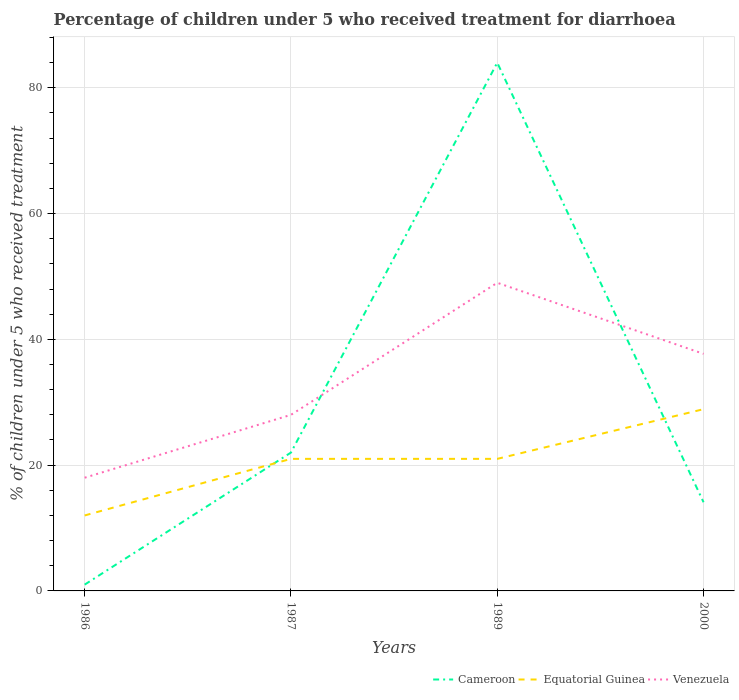How many different coloured lines are there?
Keep it short and to the point. 3. Does the line corresponding to Venezuela intersect with the line corresponding to Cameroon?
Offer a terse response. Yes. What is the total percentage of children who received treatment for diarrhoea  in Venezuela in the graph?
Provide a succinct answer. 11.3. Is the percentage of children who received treatment for diarrhoea  in Equatorial Guinea strictly greater than the percentage of children who received treatment for diarrhoea  in Cameroon over the years?
Offer a very short reply. No. How many years are there in the graph?
Your response must be concise. 4. What is the difference between two consecutive major ticks on the Y-axis?
Your response must be concise. 20. Are the values on the major ticks of Y-axis written in scientific E-notation?
Give a very brief answer. No. Does the graph contain grids?
Give a very brief answer. Yes. Where does the legend appear in the graph?
Keep it short and to the point. Bottom right. What is the title of the graph?
Your answer should be very brief. Percentage of children under 5 who received treatment for diarrhoea. Does "High income: OECD" appear as one of the legend labels in the graph?
Your answer should be compact. No. What is the label or title of the X-axis?
Your answer should be compact. Years. What is the label or title of the Y-axis?
Your answer should be very brief. % of children under 5 who received treatment. What is the % of children under 5 who received treatment of Cameroon in 1987?
Keep it short and to the point. 22. What is the % of children under 5 who received treatment in Equatorial Guinea in 1987?
Offer a very short reply. 21. What is the % of children under 5 who received treatment in Venezuela in 1987?
Give a very brief answer. 28. What is the % of children under 5 who received treatment of Equatorial Guinea in 1989?
Offer a terse response. 21. What is the % of children under 5 who received treatment of Venezuela in 1989?
Keep it short and to the point. 49. What is the % of children under 5 who received treatment in Equatorial Guinea in 2000?
Provide a succinct answer. 28.9. What is the % of children under 5 who received treatment in Venezuela in 2000?
Ensure brevity in your answer.  37.7. Across all years, what is the maximum % of children under 5 who received treatment in Cameroon?
Make the answer very short. 84. Across all years, what is the maximum % of children under 5 who received treatment of Equatorial Guinea?
Make the answer very short. 28.9. Across all years, what is the maximum % of children under 5 who received treatment in Venezuela?
Your answer should be compact. 49. Across all years, what is the minimum % of children under 5 who received treatment in Cameroon?
Give a very brief answer. 1. What is the total % of children under 5 who received treatment of Cameroon in the graph?
Your response must be concise. 121.1. What is the total % of children under 5 who received treatment in Equatorial Guinea in the graph?
Your answer should be compact. 82.9. What is the total % of children under 5 who received treatment in Venezuela in the graph?
Ensure brevity in your answer.  132.7. What is the difference between the % of children under 5 who received treatment in Cameroon in 1986 and that in 1989?
Your answer should be very brief. -83. What is the difference between the % of children under 5 who received treatment in Venezuela in 1986 and that in 1989?
Your response must be concise. -31. What is the difference between the % of children under 5 who received treatment in Cameroon in 1986 and that in 2000?
Your answer should be compact. -13.1. What is the difference between the % of children under 5 who received treatment of Equatorial Guinea in 1986 and that in 2000?
Offer a terse response. -16.9. What is the difference between the % of children under 5 who received treatment in Venezuela in 1986 and that in 2000?
Your answer should be compact. -19.7. What is the difference between the % of children under 5 who received treatment in Cameroon in 1987 and that in 1989?
Provide a short and direct response. -62. What is the difference between the % of children under 5 who received treatment of Equatorial Guinea in 1987 and that in 1989?
Make the answer very short. 0. What is the difference between the % of children under 5 who received treatment of Equatorial Guinea in 1987 and that in 2000?
Provide a short and direct response. -7.9. What is the difference between the % of children under 5 who received treatment in Cameroon in 1989 and that in 2000?
Ensure brevity in your answer.  69.9. What is the difference between the % of children under 5 who received treatment in Cameroon in 1986 and the % of children under 5 who received treatment in Equatorial Guinea in 1987?
Provide a short and direct response. -20. What is the difference between the % of children under 5 who received treatment of Cameroon in 1986 and the % of children under 5 who received treatment of Venezuela in 1987?
Make the answer very short. -27. What is the difference between the % of children under 5 who received treatment of Equatorial Guinea in 1986 and the % of children under 5 who received treatment of Venezuela in 1987?
Provide a short and direct response. -16. What is the difference between the % of children under 5 who received treatment in Cameroon in 1986 and the % of children under 5 who received treatment in Venezuela in 1989?
Provide a succinct answer. -48. What is the difference between the % of children under 5 who received treatment in Equatorial Guinea in 1986 and the % of children under 5 who received treatment in Venezuela in 1989?
Your response must be concise. -37. What is the difference between the % of children under 5 who received treatment in Cameroon in 1986 and the % of children under 5 who received treatment in Equatorial Guinea in 2000?
Your answer should be very brief. -27.9. What is the difference between the % of children under 5 who received treatment in Cameroon in 1986 and the % of children under 5 who received treatment in Venezuela in 2000?
Your answer should be compact. -36.7. What is the difference between the % of children under 5 who received treatment of Equatorial Guinea in 1986 and the % of children under 5 who received treatment of Venezuela in 2000?
Make the answer very short. -25.7. What is the difference between the % of children under 5 who received treatment of Cameroon in 1987 and the % of children under 5 who received treatment of Venezuela in 1989?
Ensure brevity in your answer.  -27. What is the difference between the % of children under 5 who received treatment in Equatorial Guinea in 1987 and the % of children under 5 who received treatment in Venezuela in 1989?
Give a very brief answer. -28. What is the difference between the % of children under 5 who received treatment in Cameroon in 1987 and the % of children under 5 who received treatment in Equatorial Guinea in 2000?
Give a very brief answer. -6.9. What is the difference between the % of children under 5 who received treatment of Cameroon in 1987 and the % of children under 5 who received treatment of Venezuela in 2000?
Offer a very short reply. -15.7. What is the difference between the % of children under 5 who received treatment of Equatorial Guinea in 1987 and the % of children under 5 who received treatment of Venezuela in 2000?
Your answer should be very brief. -16.7. What is the difference between the % of children under 5 who received treatment in Cameroon in 1989 and the % of children under 5 who received treatment in Equatorial Guinea in 2000?
Your answer should be compact. 55.1. What is the difference between the % of children under 5 who received treatment in Cameroon in 1989 and the % of children under 5 who received treatment in Venezuela in 2000?
Your response must be concise. 46.3. What is the difference between the % of children under 5 who received treatment of Equatorial Guinea in 1989 and the % of children under 5 who received treatment of Venezuela in 2000?
Make the answer very short. -16.7. What is the average % of children under 5 who received treatment in Cameroon per year?
Ensure brevity in your answer.  30.27. What is the average % of children under 5 who received treatment in Equatorial Guinea per year?
Provide a succinct answer. 20.73. What is the average % of children under 5 who received treatment of Venezuela per year?
Keep it short and to the point. 33.17. In the year 1986, what is the difference between the % of children under 5 who received treatment of Cameroon and % of children under 5 who received treatment of Equatorial Guinea?
Ensure brevity in your answer.  -11. In the year 1986, what is the difference between the % of children under 5 who received treatment of Equatorial Guinea and % of children under 5 who received treatment of Venezuela?
Make the answer very short. -6. In the year 1987, what is the difference between the % of children under 5 who received treatment in Cameroon and % of children under 5 who received treatment in Equatorial Guinea?
Your answer should be very brief. 1. In the year 1987, what is the difference between the % of children under 5 who received treatment in Cameroon and % of children under 5 who received treatment in Venezuela?
Provide a short and direct response. -6. In the year 1989, what is the difference between the % of children under 5 who received treatment in Cameroon and % of children under 5 who received treatment in Equatorial Guinea?
Your response must be concise. 63. In the year 2000, what is the difference between the % of children under 5 who received treatment in Cameroon and % of children under 5 who received treatment in Equatorial Guinea?
Make the answer very short. -14.8. In the year 2000, what is the difference between the % of children under 5 who received treatment of Cameroon and % of children under 5 who received treatment of Venezuela?
Offer a very short reply. -23.6. In the year 2000, what is the difference between the % of children under 5 who received treatment in Equatorial Guinea and % of children under 5 who received treatment in Venezuela?
Keep it short and to the point. -8.8. What is the ratio of the % of children under 5 who received treatment in Cameroon in 1986 to that in 1987?
Your answer should be compact. 0.05. What is the ratio of the % of children under 5 who received treatment of Equatorial Guinea in 1986 to that in 1987?
Make the answer very short. 0.57. What is the ratio of the % of children under 5 who received treatment of Venezuela in 1986 to that in 1987?
Offer a very short reply. 0.64. What is the ratio of the % of children under 5 who received treatment in Cameroon in 1986 to that in 1989?
Make the answer very short. 0.01. What is the ratio of the % of children under 5 who received treatment of Venezuela in 1986 to that in 1989?
Keep it short and to the point. 0.37. What is the ratio of the % of children under 5 who received treatment in Cameroon in 1986 to that in 2000?
Provide a succinct answer. 0.07. What is the ratio of the % of children under 5 who received treatment of Equatorial Guinea in 1986 to that in 2000?
Offer a terse response. 0.42. What is the ratio of the % of children under 5 who received treatment in Venezuela in 1986 to that in 2000?
Give a very brief answer. 0.48. What is the ratio of the % of children under 5 who received treatment of Cameroon in 1987 to that in 1989?
Keep it short and to the point. 0.26. What is the ratio of the % of children under 5 who received treatment of Equatorial Guinea in 1987 to that in 1989?
Your response must be concise. 1. What is the ratio of the % of children under 5 who received treatment in Cameroon in 1987 to that in 2000?
Your answer should be very brief. 1.56. What is the ratio of the % of children under 5 who received treatment in Equatorial Guinea in 1987 to that in 2000?
Your answer should be very brief. 0.73. What is the ratio of the % of children under 5 who received treatment in Venezuela in 1987 to that in 2000?
Ensure brevity in your answer.  0.74. What is the ratio of the % of children under 5 who received treatment in Cameroon in 1989 to that in 2000?
Ensure brevity in your answer.  5.96. What is the ratio of the % of children under 5 who received treatment in Equatorial Guinea in 1989 to that in 2000?
Offer a terse response. 0.73. What is the ratio of the % of children under 5 who received treatment of Venezuela in 1989 to that in 2000?
Offer a very short reply. 1.3. What is the difference between the highest and the second highest % of children under 5 who received treatment of Equatorial Guinea?
Keep it short and to the point. 7.9. What is the difference between the highest and the second highest % of children under 5 who received treatment of Venezuela?
Ensure brevity in your answer.  11.3. 